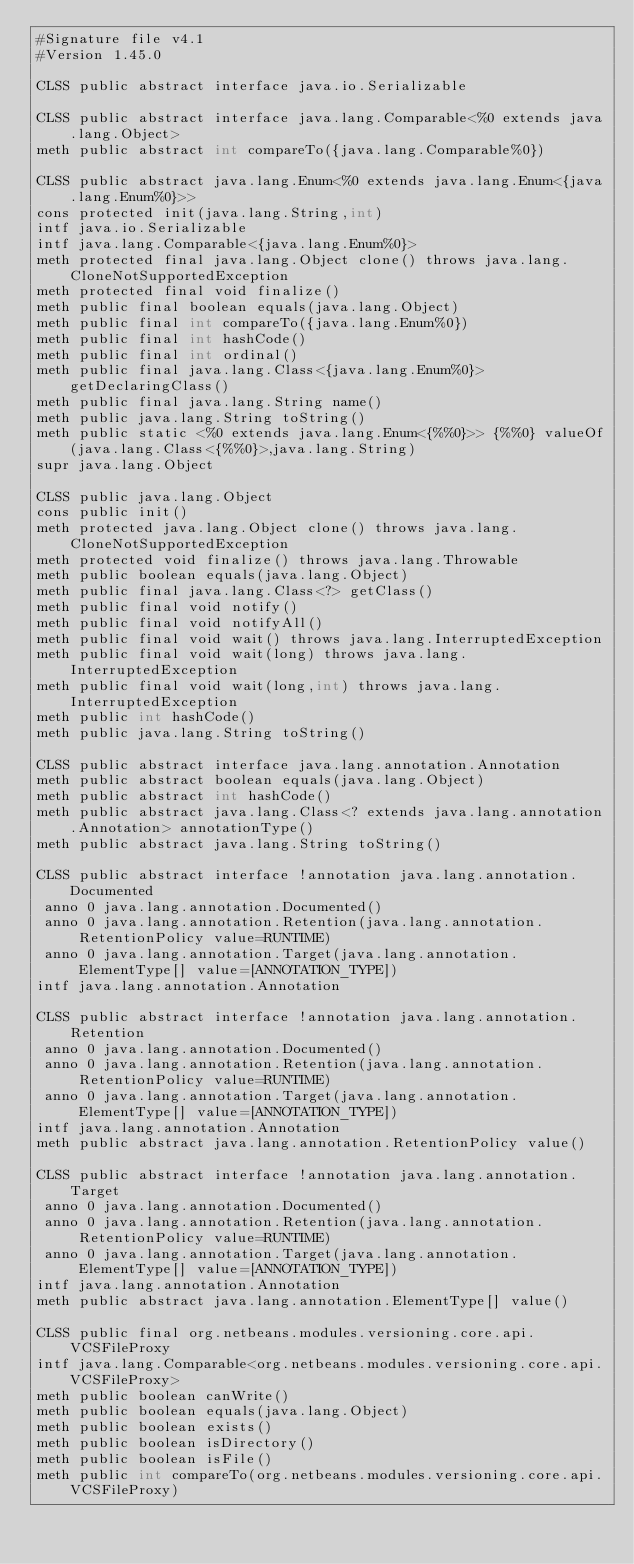<code> <loc_0><loc_0><loc_500><loc_500><_SML_>#Signature file v4.1
#Version 1.45.0

CLSS public abstract interface java.io.Serializable

CLSS public abstract interface java.lang.Comparable<%0 extends java.lang.Object>
meth public abstract int compareTo({java.lang.Comparable%0})

CLSS public abstract java.lang.Enum<%0 extends java.lang.Enum<{java.lang.Enum%0}>>
cons protected init(java.lang.String,int)
intf java.io.Serializable
intf java.lang.Comparable<{java.lang.Enum%0}>
meth protected final java.lang.Object clone() throws java.lang.CloneNotSupportedException
meth protected final void finalize()
meth public final boolean equals(java.lang.Object)
meth public final int compareTo({java.lang.Enum%0})
meth public final int hashCode()
meth public final int ordinal()
meth public final java.lang.Class<{java.lang.Enum%0}> getDeclaringClass()
meth public final java.lang.String name()
meth public java.lang.String toString()
meth public static <%0 extends java.lang.Enum<{%%0}>> {%%0} valueOf(java.lang.Class<{%%0}>,java.lang.String)
supr java.lang.Object

CLSS public java.lang.Object
cons public init()
meth protected java.lang.Object clone() throws java.lang.CloneNotSupportedException
meth protected void finalize() throws java.lang.Throwable
meth public boolean equals(java.lang.Object)
meth public final java.lang.Class<?> getClass()
meth public final void notify()
meth public final void notifyAll()
meth public final void wait() throws java.lang.InterruptedException
meth public final void wait(long) throws java.lang.InterruptedException
meth public final void wait(long,int) throws java.lang.InterruptedException
meth public int hashCode()
meth public java.lang.String toString()

CLSS public abstract interface java.lang.annotation.Annotation
meth public abstract boolean equals(java.lang.Object)
meth public abstract int hashCode()
meth public abstract java.lang.Class<? extends java.lang.annotation.Annotation> annotationType()
meth public abstract java.lang.String toString()

CLSS public abstract interface !annotation java.lang.annotation.Documented
 anno 0 java.lang.annotation.Documented()
 anno 0 java.lang.annotation.Retention(java.lang.annotation.RetentionPolicy value=RUNTIME)
 anno 0 java.lang.annotation.Target(java.lang.annotation.ElementType[] value=[ANNOTATION_TYPE])
intf java.lang.annotation.Annotation

CLSS public abstract interface !annotation java.lang.annotation.Retention
 anno 0 java.lang.annotation.Documented()
 anno 0 java.lang.annotation.Retention(java.lang.annotation.RetentionPolicy value=RUNTIME)
 anno 0 java.lang.annotation.Target(java.lang.annotation.ElementType[] value=[ANNOTATION_TYPE])
intf java.lang.annotation.Annotation
meth public abstract java.lang.annotation.RetentionPolicy value()

CLSS public abstract interface !annotation java.lang.annotation.Target
 anno 0 java.lang.annotation.Documented()
 anno 0 java.lang.annotation.Retention(java.lang.annotation.RetentionPolicy value=RUNTIME)
 anno 0 java.lang.annotation.Target(java.lang.annotation.ElementType[] value=[ANNOTATION_TYPE])
intf java.lang.annotation.Annotation
meth public abstract java.lang.annotation.ElementType[] value()

CLSS public final org.netbeans.modules.versioning.core.api.VCSFileProxy
intf java.lang.Comparable<org.netbeans.modules.versioning.core.api.VCSFileProxy>
meth public boolean canWrite()
meth public boolean equals(java.lang.Object)
meth public boolean exists()
meth public boolean isDirectory()
meth public boolean isFile()
meth public int compareTo(org.netbeans.modules.versioning.core.api.VCSFileProxy)</code> 